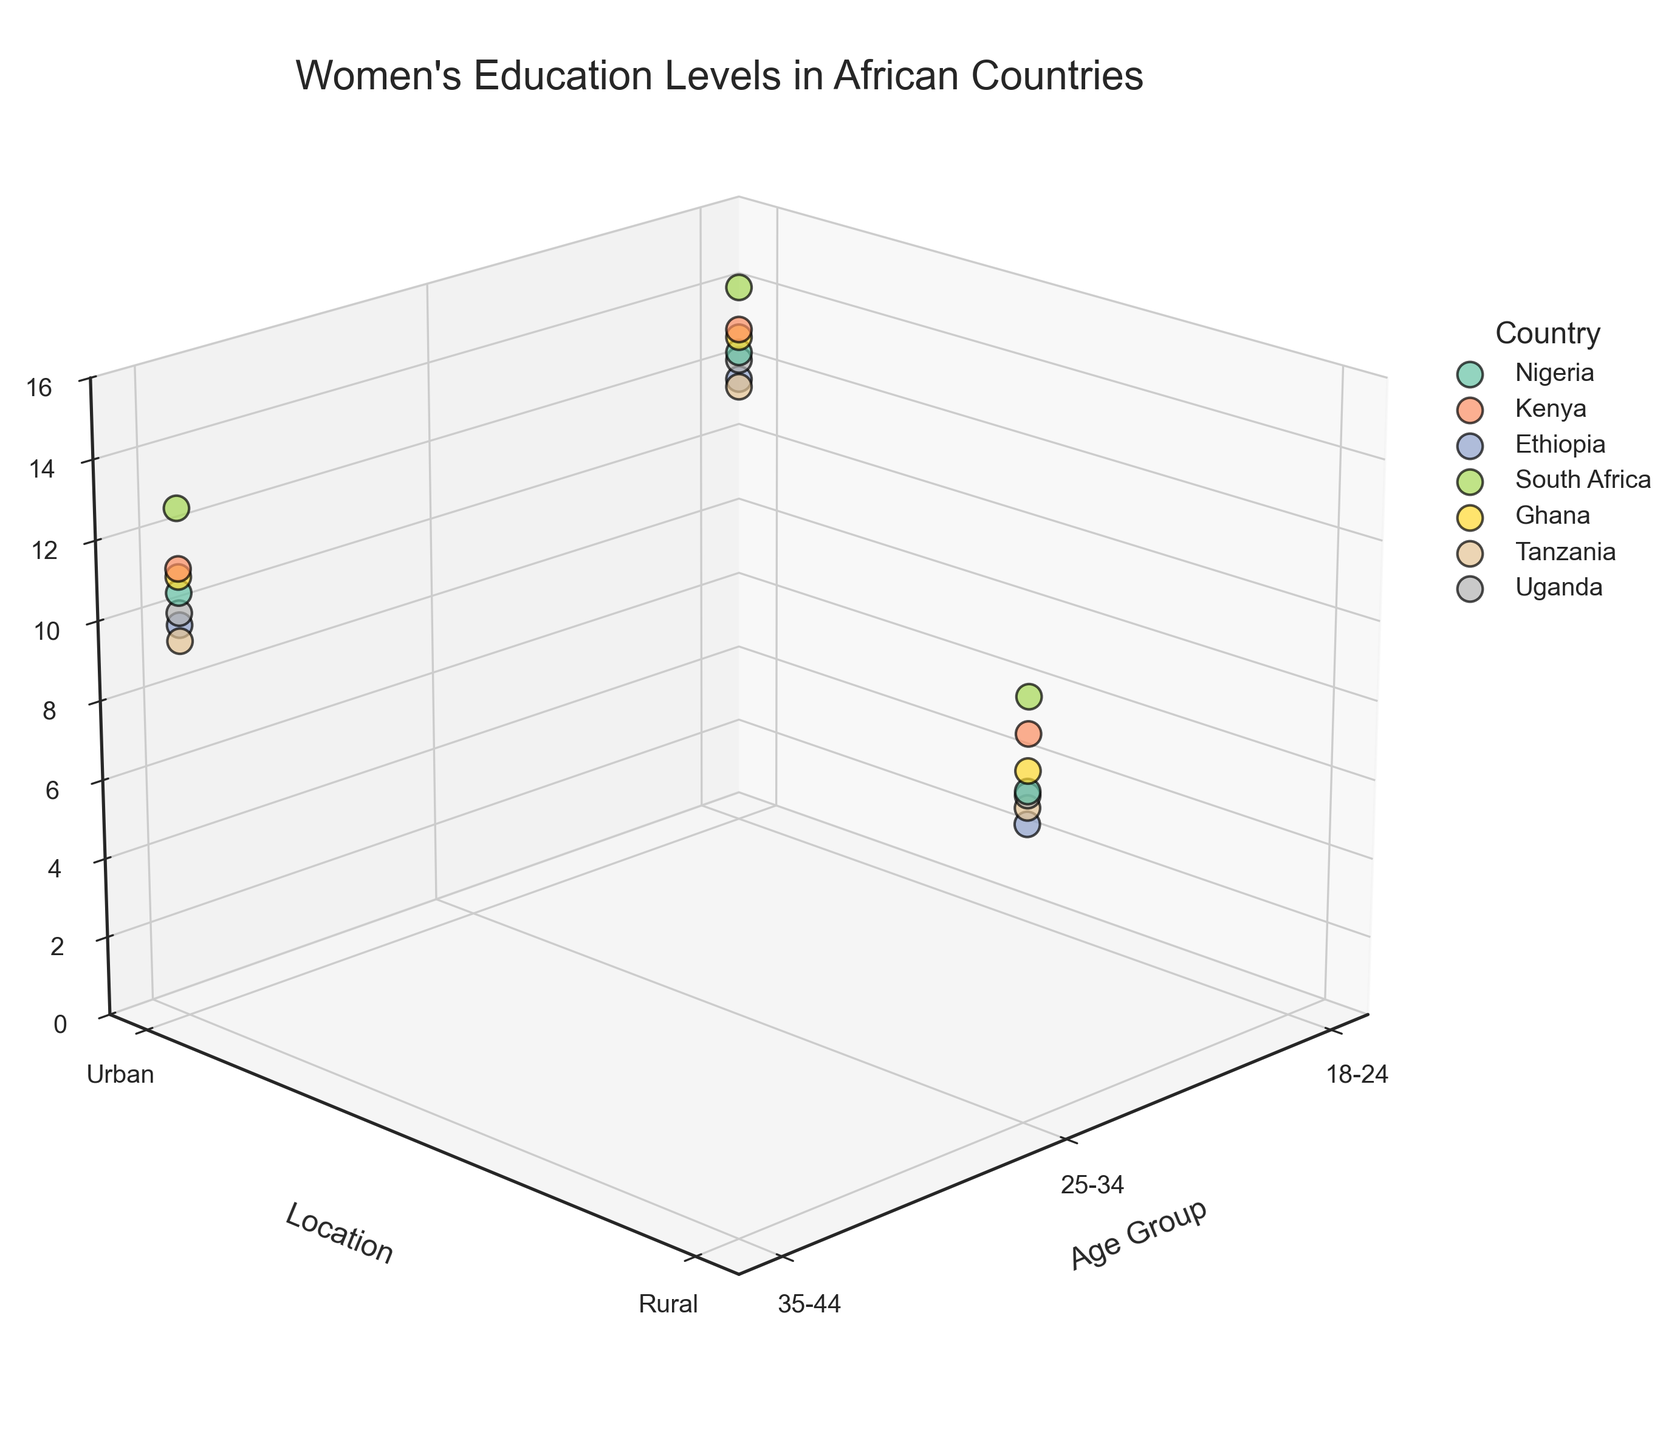How many age groups are represented in the figure? There are clear labels on the x-axis representing age groups as '18-24', '25-34', and '35-44'. Counting these groups gives us a total of three age groups.
Answer: Three Which location has the highest recorded education level in the figure, and in which country? To find the highest recorded education level, one must look at the z-axis values. The maximum education level (14.2 years) is in the 'Urban' location of South Africa.
Answer: Urban in South Africa Are education levels generally higher in urban or rural areas across all countries? By comparing the z-axis heights (education levels) for each location ('Urban' or 'Rural'), it becomes evident that Urban locations typically have higher education levels compared to Rural locations across all represented countries.
Answer: Urban What is the approximate difference in education levels between the age groups 18-24 and 25-34 in Nigeria? In Nigeria, the education level for the age group 18-24 is roughly 12.5 years, and for the age group 25-34 it is about 8.2 years. The difference can be calculated as 12.5 - 8.2 = 4.3 years.
Answer: 4.3 years Which country has the most balanced education levels between urban and rural locations? By examining the spread along the y-axis (Location) and the close proximity of their z-axis values (Education Levels), Kenya appears to have the most balanced education levels between urban (13.1 years) and rural (9.6 years) locations. The difference is 3.5 years, which is the smallest among the countries.
Answer: Kenya What's the range of education levels for the age group 35-44 across all countries? The range of education levels for the age group 35-44 can be found by identifying the maximum and minimum z-axis values for this age group. The highest is 12.8 years (South Africa, Urban), and the lowest is 9.5 years (Tanzania, Urban). Thus, the range is 12.8 - 9.5 = 3.3 years.
Answer: 3.3 years How does the average education level of the age group 18-24 in urban locations compare to that in rural locations across all countries? To compare, average the education levels of 18-24 in urban locations (Nigeria 12.5, Kenya 13.1, Ethiopia 11.8, South Africa 14.2, Ghana 12.9, Tanzania 11.6, Uganda 12.3) which sum up to 88.4, then divide by 7 = 12.63 years. For rural (it is not available), so the comparison focuses on the urban value's high availability compared to non-existent rural data for this specific age group.
Answer: Urban higher than Rural What pattern can be observed regarding the highest education levels for the age group 35-44 across countries? Observing the highest educational levels across countries for age group 35-44 on the z-axis, in Urban areas, generally shows an upward trend – specifically 10.7 (Nigeria), 11.3 (Kenya), 9.9 (Ethiopia), 12.8 (South Africa), 11.1 (Ghana), 9.5 (Tanzania), 10.2 (Uganda). This implies Urban areas tend to have higher education levels consistently across this age demographic.
Answer: Urban areas generally have higher levels Which country displays the greatest decrease in education level from the age group 18-24 to 25-34? Observing education levels in Nigeria -15 to 25-34 transition shows a decline from 12.5 to 8.2 years, which is a decrease of 4.3 years. Comparing similar transitions among other countries, this represents the most significant drop.
Answer: Nigeria Do rural locations exhibit more variability in education levels across different age groups compared to urban locations? Reviewing the z-axis for each country's 'Rural' location in age transitions (e.g., Nigeria 8.2 for 25-34, Kenya 9.6, Ethiopia 7.4, South Africa 10.5, Ghana 8.7, Tanzania 7.8, Uganda 8.1) reveals a more significant spread compared to the relatively compact values in 'Urban' groupings with sharper rises.
Answer: Yes 